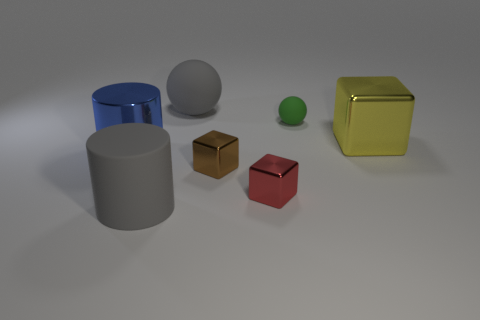What number of metallic things are right of the big object that is in front of the big metal thing in front of the yellow object?
Offer a terse response. 3. There is a yellow thing; is it the same shape as the tiny brown metal object that is right of the large blue metallic thing?
Make the answer very short. Yes. Are there more gray things than shiny things?
Offer a terse response. No. Is there anything else that has the same size as the gray cylinder?
Keep it short and to the point. Yes. There is a large gray thing that is behind the tiny brown cube; is its shape the same as the green rubber thing?
Your response must be concise. Yes. Are there more yellow metallic blocks on the left side of the gray rubber ball than tiny purple things?
Offer a very short reply. No. What color is the rubber thing right of the large gray thing behind the yellow thing?
Ensure brevity in your answer.  Green. How many large objects are there?
Offer a terse response. 4. What number of things are to the right of the red object and behind the yellow block?
Provide a short and direct response. 1. Are there any other things that have the same shape as the tiny green rubber object?
Your answer should be compact. Yes. 